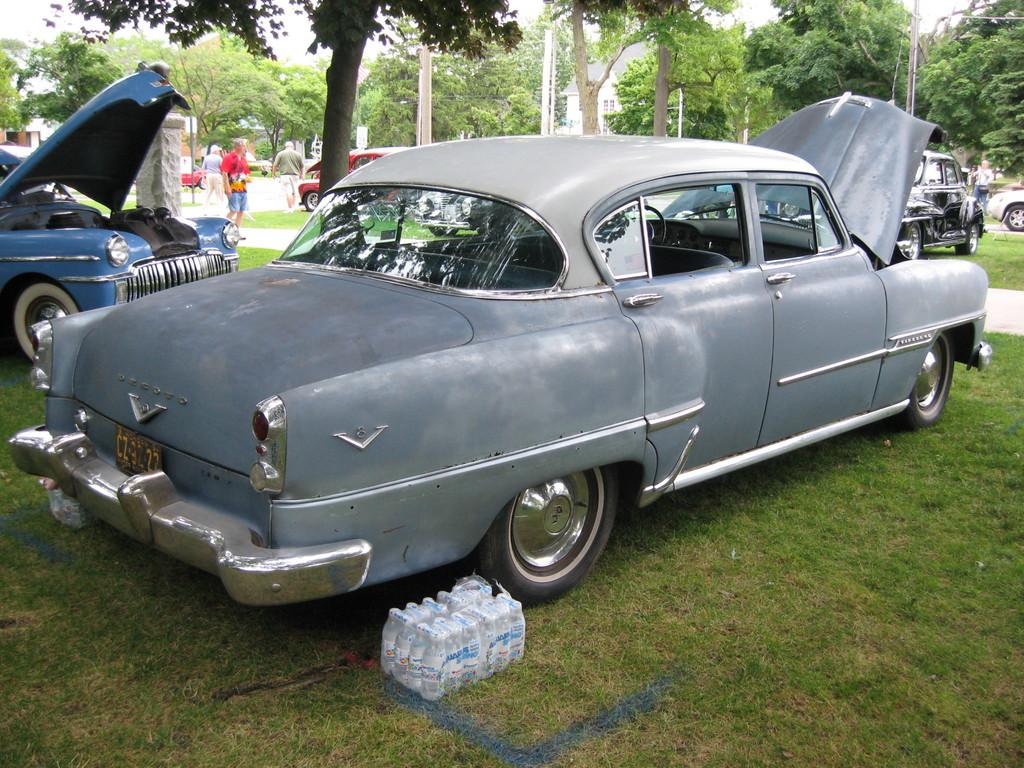What type of vehicle is in the image? There is a grey car in the image. What can be seen at the bottom of the image? There are packed bottles at the bottom of the image. What type of natural scenery is visible in the image? There are trees visible at the backside of the image. Can you see a snake slithering through the trees in the image? There is no snake visible in the image; only trees are present. 